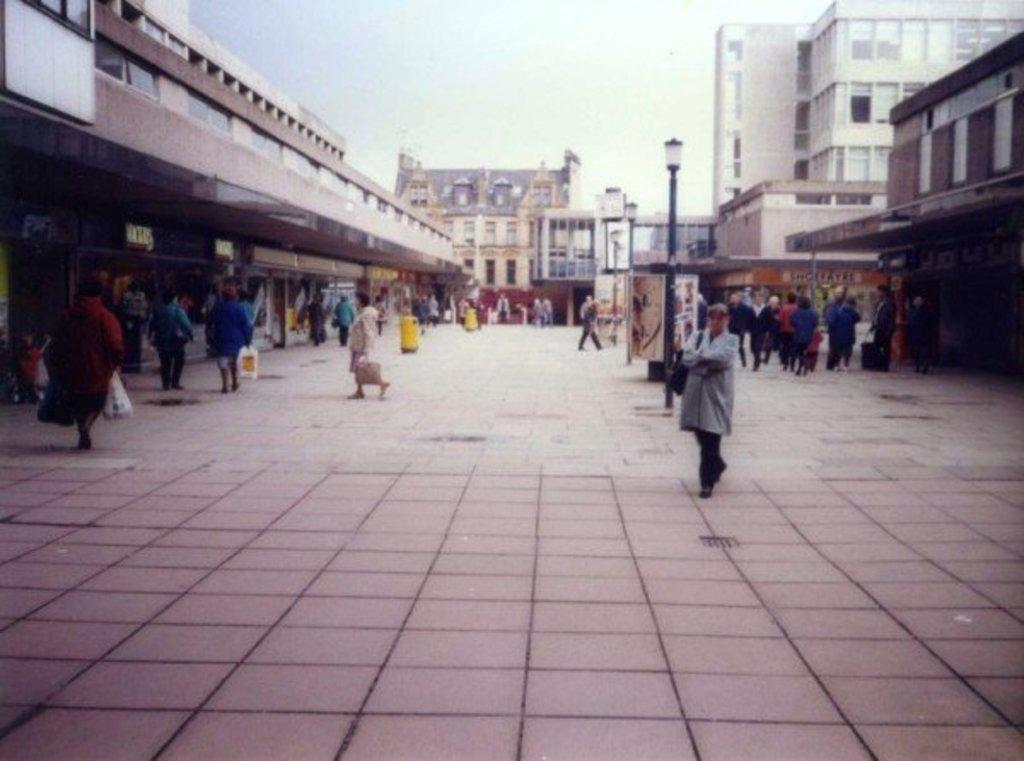What is located in the foreground of the image? There are people in the foreground of the image. What is the position of the people in the image? The people are on the ground. What structures can be seen in the middle of the image? There are buildings in the middle of the image. What is visible at the top of the image? The sky is visible at the top of the image. What title does the beggar in the image hold? There is no beggar present in the image. What idea does the image represent? The image does not represent a specific idea; it simply shows people, buildings, and the sky. 